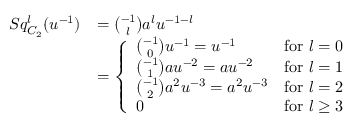<formula> <loc_0><loc_0><loc_500><loc_500>\begin{array} { r l } { S q _ { C _ { 2 } } ^ { l } ( u ^ { - 1 } ) } & { = \binom { - 1 } { l } a ^ { l } u ^ { - 1 - l } } \\ & { = \left \{ \begin{array} { l l } { \binom { - 1 } { 0 } u ^ { - 1 } = u ^ { - 1 } } & { f o r \ l = 0 } \\ { \binom { - 1 } { 1 } a u ^ { - 2 } = a u ^ { - 2 } } & { f o r \ l = 1 } \\ { \binom { - 1 } { 2 } a ^ { 2 } u ^ { - 3 } = a ^ { 2 } u ^ { - 3 } } & { f o r \ l = 2 } \\ { 0 } & { f o r \ l \geq 3 } \end{array} } \end{array}</formula> 